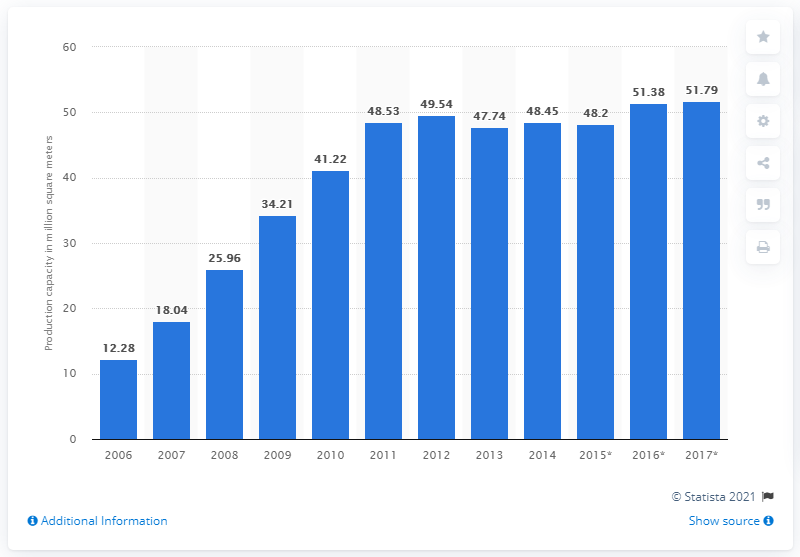Give some essential details in this illustration. The SEC's production capacity in square meters in 2014 was 48.2. 